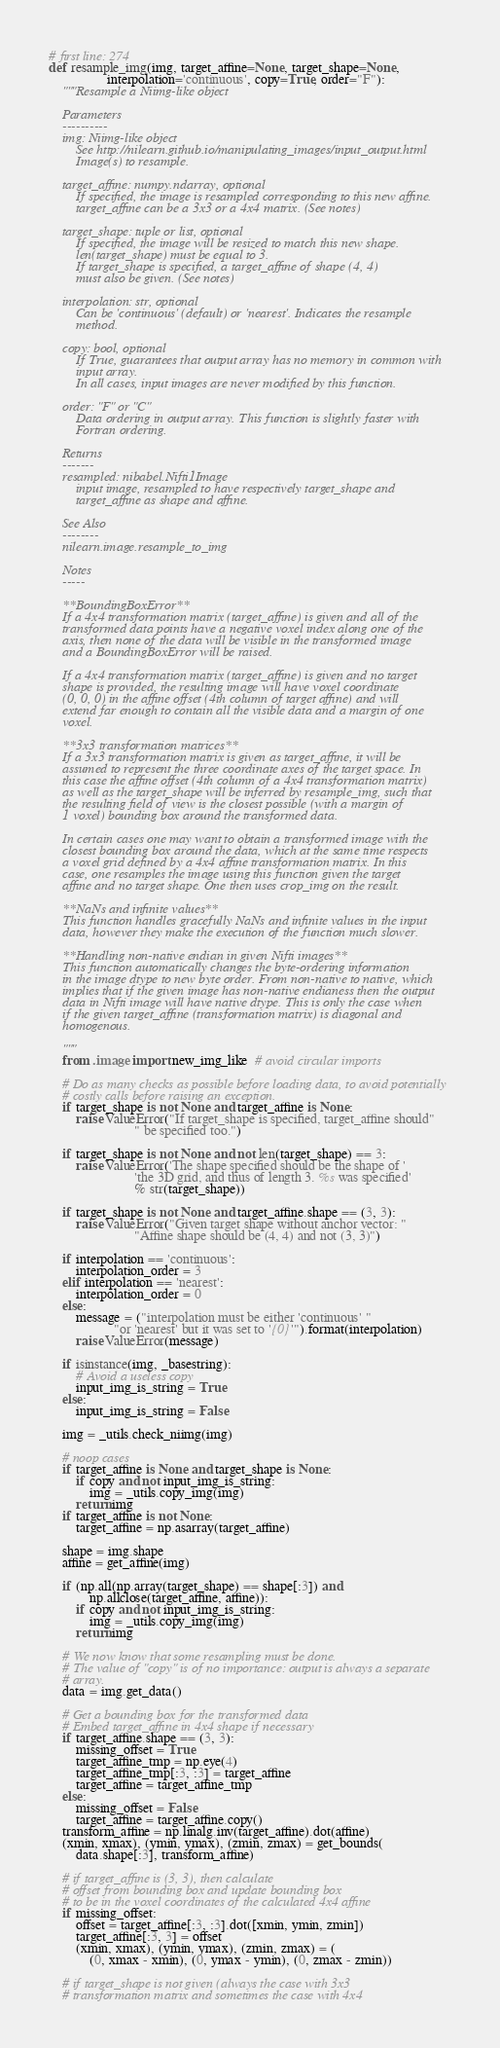Convert code to text. <code><loc_0><loc_0><loc_500><loc_500><_Python_># first line: 274
def resample_img(img, target_affine=None, target_shape=None,
                 interpolation='continuous', copy=True, order="F"):
    """Resample a Niimg-like object

    Parameters
    ----------
    img: Niimg-like object
        See http://nilearn.github.io/manipulating_images/input_output.html
        Image(s) to resample.

    target_affine: numpy.ndarray, optional
        If specified, the image is resampled corresponding to this new affine.
        target_affine can be a 3x3 or a 4x4 matrix. (See notes)

    target_shape: tuple or list, optional
        If specified, the image will be resized to match this new shape.
        len(target_shape) must be equal to 3.
        If target_shape is specified, a target_affine of shape (4, 4)
        must also be given. (See notes)

    interpolation: str, optional
        Can be 'continuous' (default) or 'nearest'. Indicates the resample
        method.

    copy: bool, optional
        If True, guarantees that output array has no memory in common with
        input array.
        In all cases, input images are never modified by this function.

    order: "F" or "C"
        Data ordering in output array. This function is slightly faster with
        Fortran ordering.

    Returns
    -------
    resampled: nibabel.Nifti1Image
        input image, resampled to have respectively target_shape and
        target_affine as shape and affine.

    See Also
    --------
    nilearn.image.resample_to_img

    Notes
    -----

    **BoundingBoxError**
    If a 4x4 transformation matrix (target_affine) is given and all of the
    transformed data points have a negative voxel index along one of the
    axis, then none of the data will be visible in the transformed image
    and a BoundingBoxError will be raised.

    If a 4x4 transformation matrix (target_affine) is given and no target
    shape is provided, the resulting image will have voxel coordinate
    (0, 0, 0) in the affine offset (4th column of target affine) and will
    extend far enough to contain all the visible data and a margin of one
    voxel.

    **3x3 transformation matrices**
    If a 3x3 transformation matrix is given as target_affine, it will be
    assumed to represent the three coordinate axes of the target space. In
    this case the affine offset (4th column of a 4x4 transformation matrix)
    as well as the target_shape will be inferred by resample_img, such that
    the resulting field of view is the closest possible (with a margin of
    1 voxel) bounding box around the transformed data.

    In certain cases one may want to obtain a transformed image with the
    closest bounding box around the data, which at the same time respects
    a voxel grid defined by a 4x4 affine transformation matrix. In this
    case, one resamples the image using this function given the target
    affine and no target shape. One then uses crop_img on the result.

    **NaNs and infinite values**
    This function handles gracefully NaNs and infinite values in the input
    data, however they make the execution of the function much slower.

    **Handling non-native endian in given Nifti images**
    This function automatically changes the byte-ordering information
    in the image dtype to new byte order. From non-native to native, which
    implies that if the given image has non-native endianess then the output
    data in Nifti image will have native dtype. This is only the case when
    if the given target_affine (transformation matrix) is diagonal and
    homogenous.

    """
    from .image import new_img_like  # avoid circular imports

    # Do as many checks as possible before loading data, to avoid potentially
    # costly calls before raising an exception.
    if target_shape is not None and target_affine is None:
        raise ValueError("If target_shape is specified, target_affine should"
                         " be specified too.")

    if target_shape is not None and not len(target_shape) == 3:
        raise ValueError('The shape specified should be the shape of '
                         'the 3D grid, and thus of length 3. %s was specified'
                         % str(target_shape))

    if target_shape is not None and target_affine.shape == (3, 3):
        raise ValueError("Given target shape without anchor vector: "
                         "Affine shape should be (4, 4) and not (3, 3)")

    if interpolation == 'continuous':
        interpolation_order = 3
    elif interpolation == 'nearest':
        interpolation_order = 0
    else:
        message = ("interpolation must be either 'continuous' "
                   "or 'nearest' but it was set to '{0}'").format(interpolation)
        raise ValueError(message)

    if isinstance(img, _basestring):
        # Avoid a useless copy
        input_img_is_string = True
    else:
        input_img_is_string = False

    img = _utils.check_niimg(img)

    # noop cases
    if target_affine is None and target_shape is None:
        if copy and not input_img_is_string:
            img = _utils.copy_img(img)
        return img
    if target_affine is not None:
        target_affine = np.asarray(target_affine)

    shape = img.shape
    affine = get_affine(img)

    if (np.all(np.array(target_shape) == shape[:3]) and
            np.allclose(target_affine, affine)):
        if copy and not input_img_is_string:
            img = _utils.copy_img(img)
        return img

    # We now know that some resampling must be done.
    # The value of "copy" is of no importance: output is always a separate
    # array.
    data = img.get_data()

    # Get a bounding box for the transformed data
    # Embed target_affine in 4x4 shape if necessary
    if target_affine.shape == (3, 3):
        missing_offset = True
        target_affine_tmp = np.eye(4)
        target_affine_tmp[:3, :3] = target_affine
        target_affine = target_affine_tmp
    else:
        missing_offset = False
        target_affine = target_affine.copy()
    transform_affine = np.linalg.inv(target_affine).dot(affine)
    (xmin, xmax), (ymin, ymax), (zmin, zmax) = get_bounds(
        data.shape[:3], transform_affine)

    # if target_affine is (3, 3), then calculate
    # offset from bounding box and update bounding box
    # to be in the voxel coordinates of the calculated 4x4 affine
    if missing_offset:
        offset = target_affine[:3, :3].dot([xmin, ymin, zmin])
        target_affine[:3, 3] = offset
        (xmin, xmax), (ymin, ymax), (zmin, zmax) = (
            (0, xmax - xmin), (0, ymax - ymin), (0, zmax - zmin))

    # if target_shape is not given (always the case with 3x3
    # transformation matrix and sometimes the case with 4x4</code> 